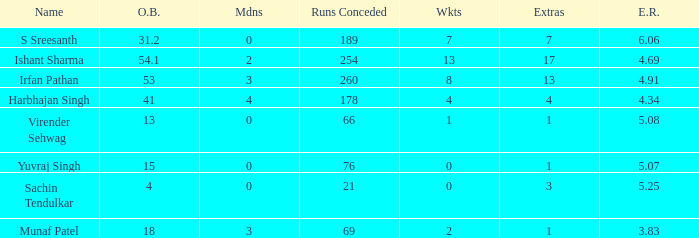Name the maaidens where overs bowled is 13 0.0. 